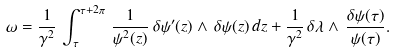<formula> <loc_0><loc_0><loc_500><loc_500>\omega = \frac { 1 } { \gamma ^ { 2 } } \, \int _ { \tau } ^ { \tau + 2 \pi } \, \frac { 1 } { \psi ^ { 2 } ( z ) } \, \delta \psi ^ { \prime } ( z ) \wedge \, \delta \psi ( z ) \, d z + \frac { 1 } { \gamma ^ { 2 } } \, \delta \lambda \wedge \, \frac { \delta \psi ( \tau ) } { \psi ( \tau ) } .</formula> 